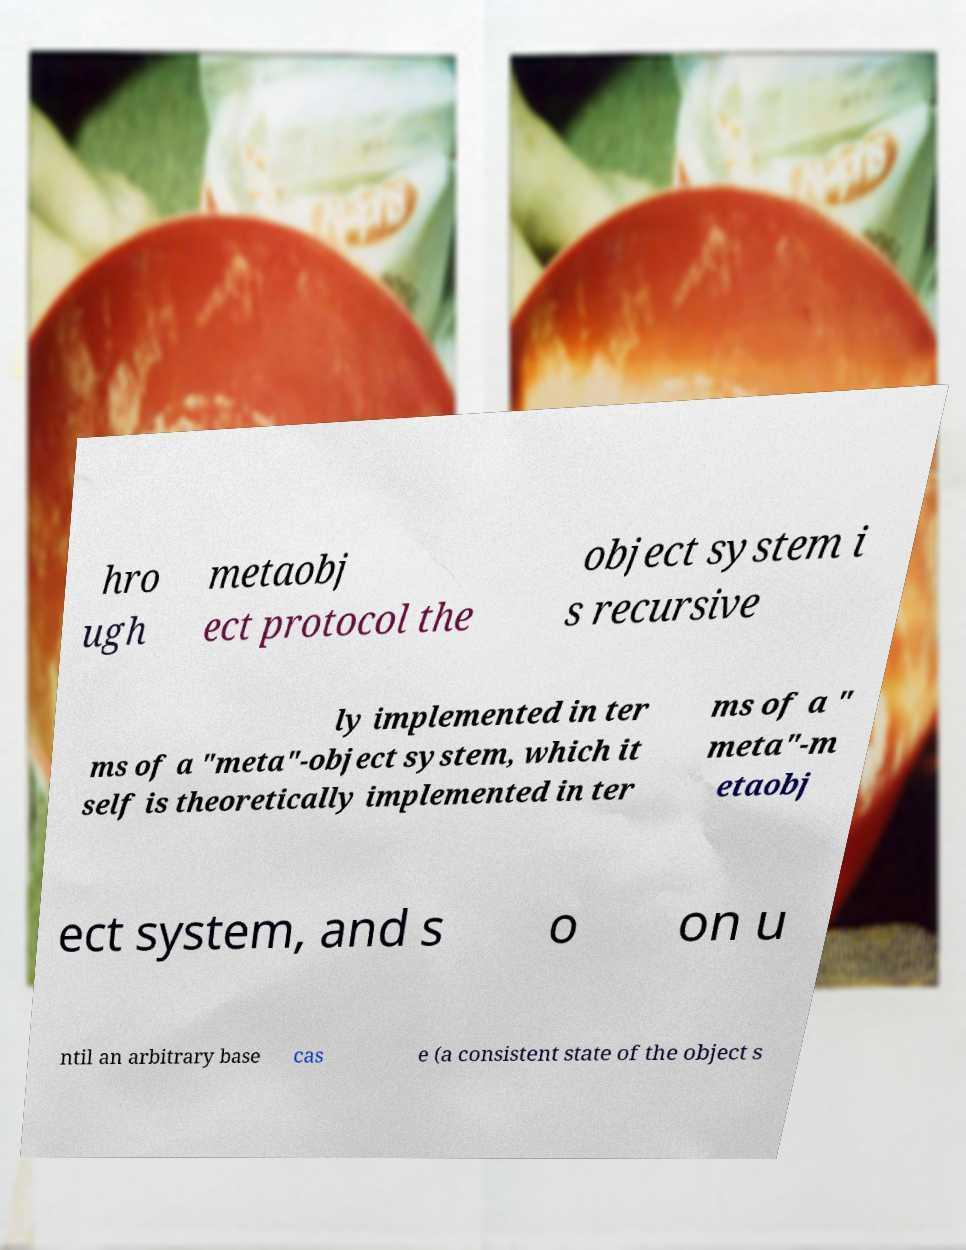Can you accurately transcribe the text from the provided image for me? hro ugh metaobj ect protocol the object system i s recursive ly implemented in ter ms of a "meta"-object system, which it self is theoretically implemented in ter ms of a " meta"-m etaobj ect system, and s o on u ntil an arbitrary base cas e (a consistent state of the object s 